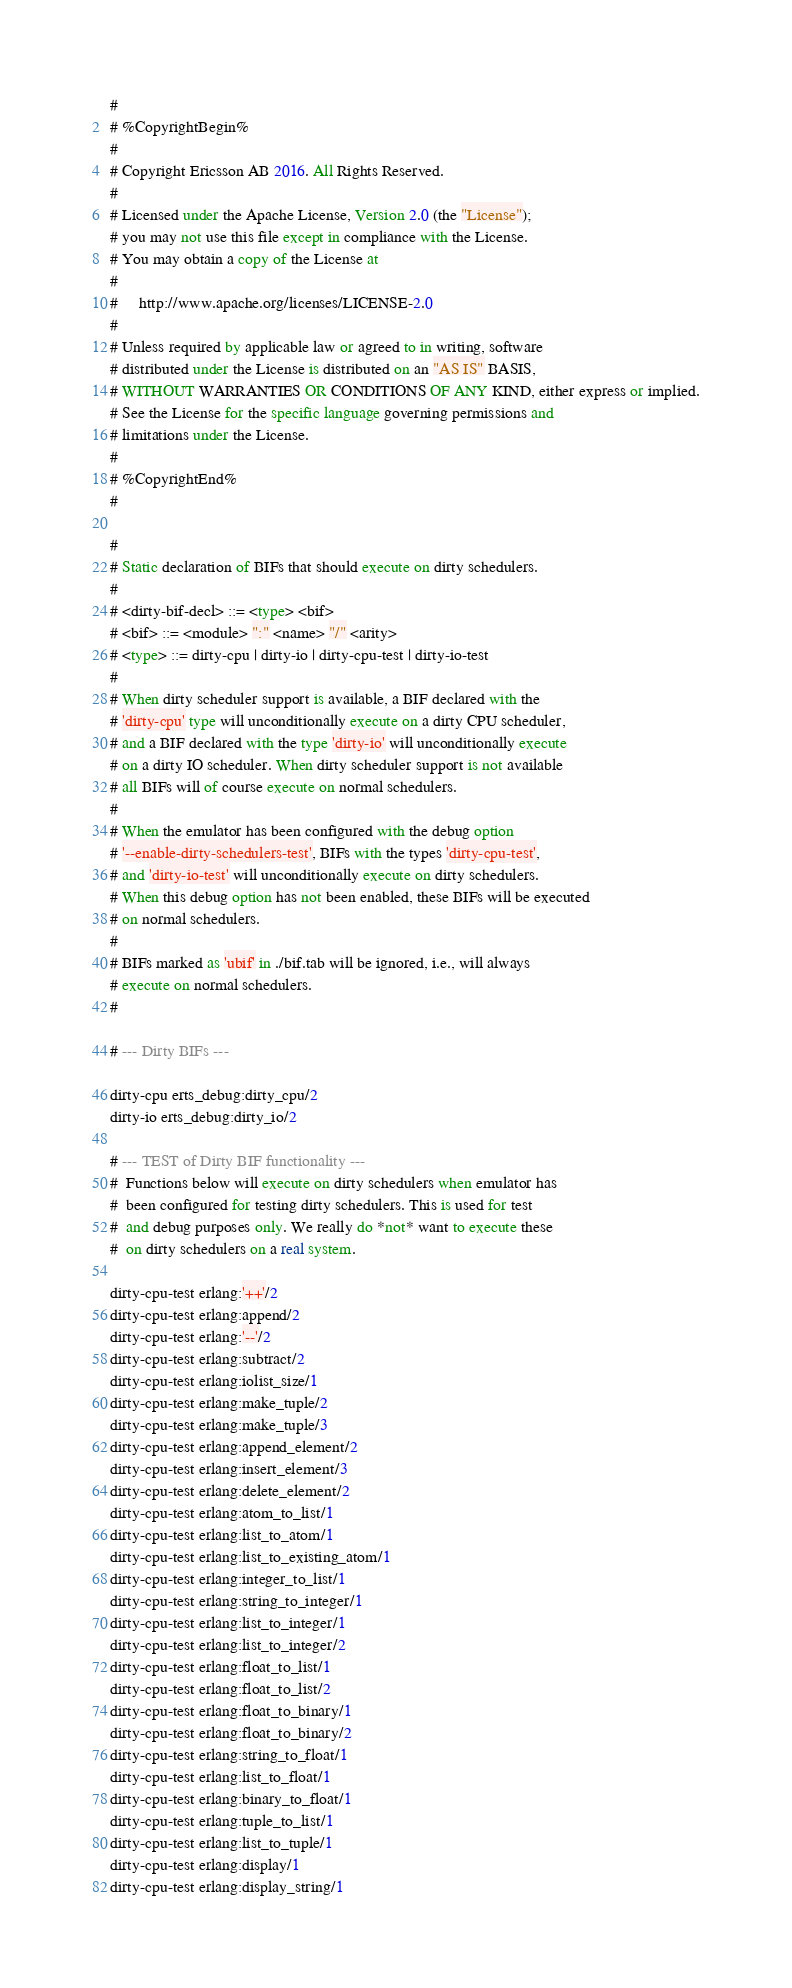Convert code to text. <code><loc_0><loc_0><loc_500><loc_500><_SQL_>#
# %CopyrightBegin%
#
# Copyright Ericsson AB 2016. All Rights Reserved.
#
# Licensed under the Apache License, Version 2.0 (the "License");
# you may not use this file except in compliance with the License.
# You may obtain a copy of the License at
#
#     http://www.apache.org/licenses/LICENSE-2.0
#
# Unless required by applicable law or agreed to in writing, software
# distributed under the License is distributed on an "AS IS" BASIS,
# WITHOUT WARRANTIES OR CONDITIONS OF ANY KIND, either express or implied.
# See the License for the specific language governing permissions and
# limitations under the License.
#
# %CopyrightEnd%
#

#
# Static declaration of BIFs that should execute on dirty schedulers.
#
# <dirty-bif-decl> ::= <type> <bif>
# <bif> ::= <module> ":" <name> "/" <arity>
# <type> ::= dirty-cpu | dirty-io | dirty-cpu-test | dirty-io-test
#
# When dirty scheduler support is available, a BIF declared with the
# 'dirty-cpu' type will unconditionally execute on a dirty CPU scheduler,
# and a BIF declared with the type 'dirty-io' will unconditionally execute
# on a dirty IO scheduler. When dirty scheduler support is not available
# all BIFs will of course execute on normal schedulers.
#
# When the emulator has been configured with the debug option
# '--enable-dirty-schedulers-test', BIFs with the types 'dirty-cpu-test',
# and 'dirty-io-test' will unconditionally execute on dirty schedulers.
# When this debug option has not been enabled, these BIFs will be executed
# on normal schedulers.
#
# BIFs marked as 'ubif' in ./bif.tab will be ignored, i.e., will always
# execute on normal schedulers.
#

# --- Dirty BIFs ---

dirty-cpu erts_debug:dirty_cpu/2
dirty-io erts_debug:dirty_io/2

# --- TEST of Dirty BIF functionality ---
#  Functions below will execute on dirty schedulers when emulator has
#  been configured for testing dirty schedulers. This is used for test
#  and debug purposes only. We really do *not* want to execute these
#  on dirty schedulers on a real system.

dirty-cpu-test erlang:'++'/2
dirty-cpu-test erlang:append/2
dirty-cpu-test erlang:'--'/2
dirty-cpu-test erlang:subtract/2
dirty-cpu-test erlang:iolist_size/1
dirty-cpu-test erlang:make_tuple/2
dirty-cpu-test erlang:make_tuple/3
dirty-cpu-test erlang:append_element/2
dirty-cpu-test erlang:insert_element/3
dirty-cpu-test erlang:delete_element/2
dirty-cpu-test erlang:atom_to_list/1
dirty-cpu-test erlang:list_to_atom/1
dirty-cpu-test erlang:list_to_existing_atom/1
dirty-cpu-test erlang:integer_to_list/1
dirty-cpu-test erlang:string_to_integer/1
dirty-cpu-test erlang:list_to_integer/1
dirty-cpu-test erlang:list_to_integer/2
dirty-cpu-test erlang:float_to_list/1
dirty-cpu-test erlang:float_to_list/2
dirty-cpu-test erlang:float_to_binary/1
dirty-cpu-test erlang:float_to_binary/2
dirty-cpu-test erlang:string_to_float/1
dirty-cpu-test erlang:list_to_float/1
dirty-cpu-test erlang:binary_to_float/1
dirty-cpu-test erlang:tuple_to_list/1
dirty-cpu-test erlang:list_to_tuple/1
dirty-cpu-test erlang:display/1
dirty-cpu-test erlang:display_string/1
</code> 